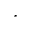<formula> <loc_0><loc_0><loc_500><loc_500>^ { * }</formula> 